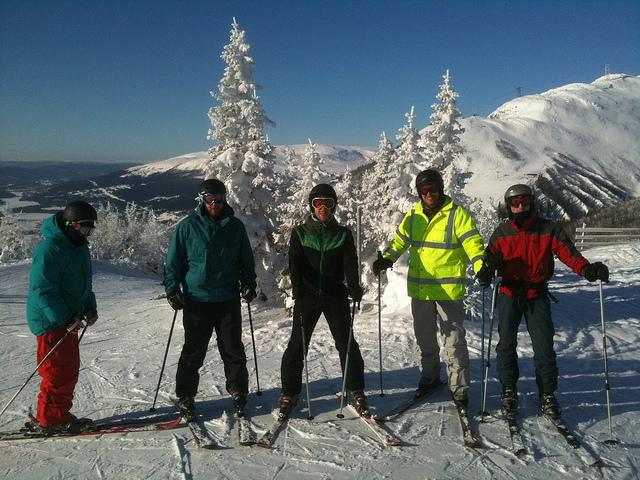What are the people doing?
Be succinct. Skiing. How many people in the image are wearing blue?
Write a very short answer. 2. How many people are shown?
Answer briefly. 5. Is the snow deep?
Be succinct. No. What year was this taken?
Give a very brief answer. 2010. Where are the people?
Answer briefly. Mountain. Are any of these people overweight?
Answer briefly. No. What kind of glasses are these people wearing?
Quick response, please. Goggles. How many people are there?
Be succinct. 5. 